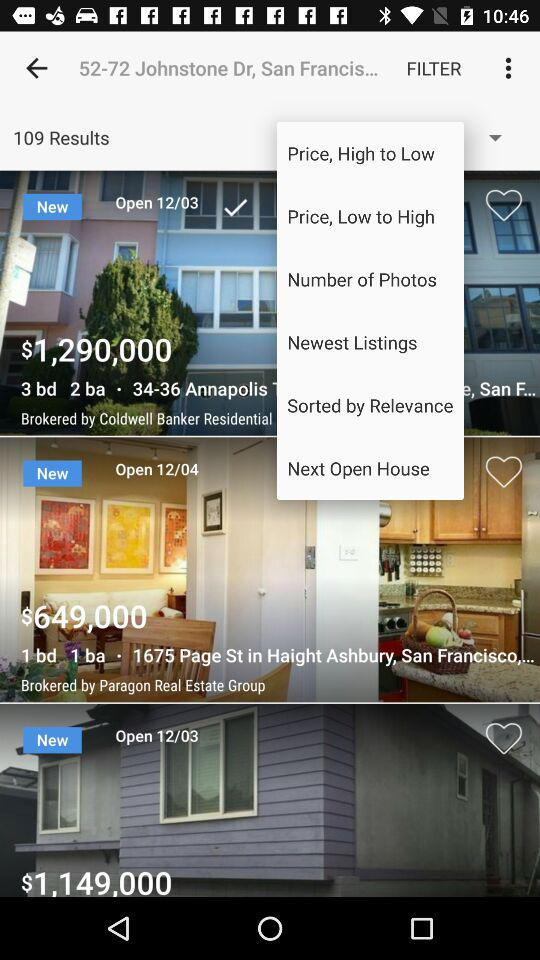What is the price of the place brokered by the Paragon Real Estate Group? The price of the place brokered by the Paragon Real Estate Group is $649,000. 